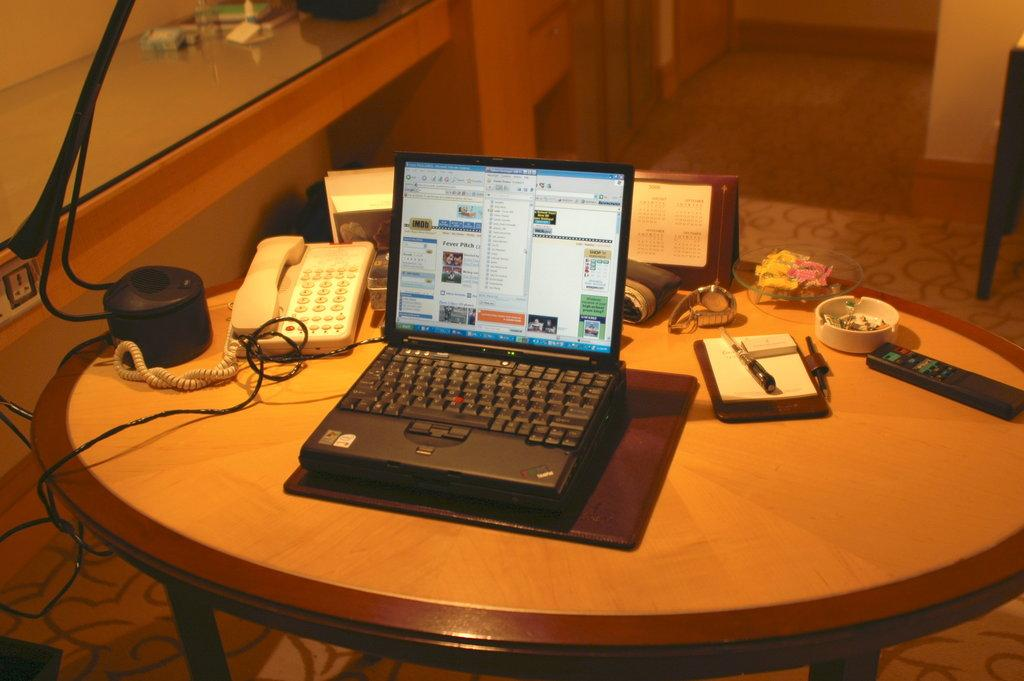What piece of furniture is present in the image? There is a table in the image. What electronic devices can be seen on the table? There is a cell phone and a laptop on the table. What accessory is visible on the table? There is a watch on the table. What type of container is on the table? There is a cup on the table. What device for controlling electronic equipment is on the table? There is a remote on the table. What other piece of furniture is in the image? There is a desk in the image. What is placed on the desk? There are objects placed on the desk. What type of powder can be seen covering the objects on the table? There is no powder visible on the objects in the image. What type of twig is used as a decoration on the table? There is no twig present on the table in the image. 